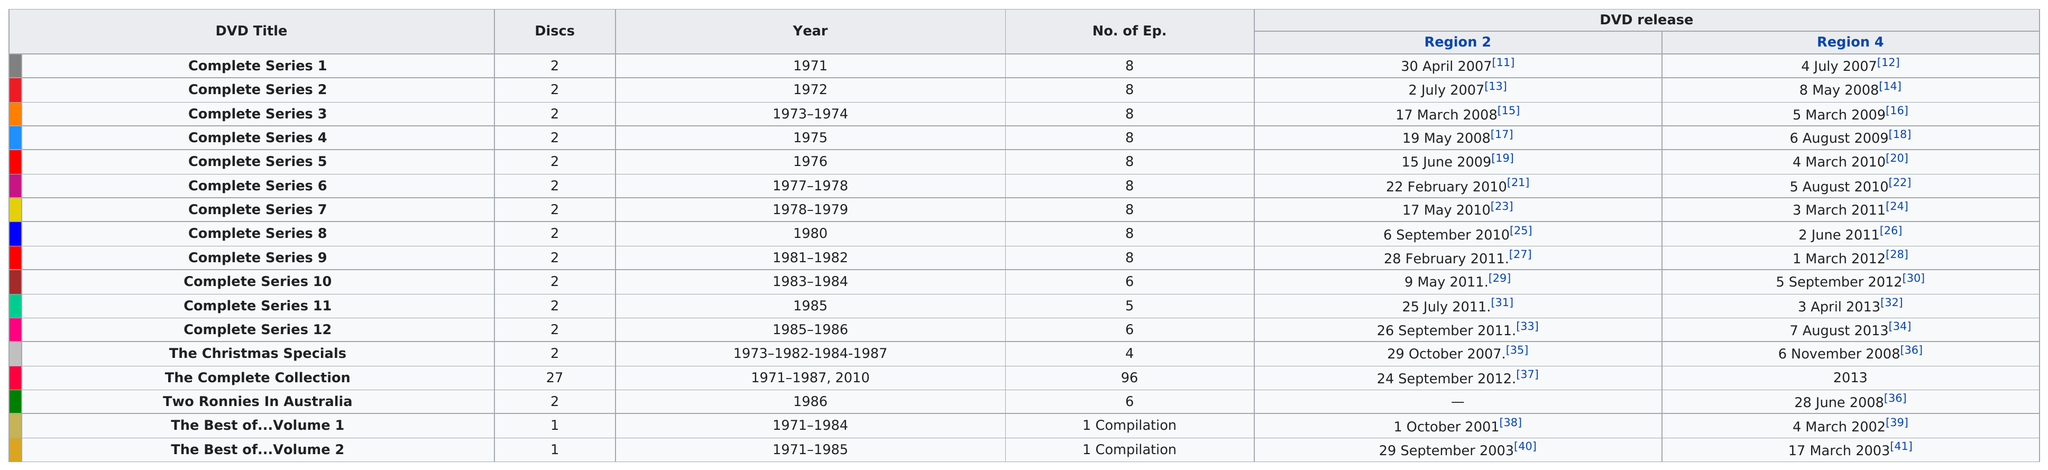Indicate a few pertinent items in this graphic. The phrase "what is previous to complete series 10? Complete Series 9.." is asking for information about the previous series to the currently available series, which is series 10, and also asking for information about the complete series of series 9. The DVD contains episodes that are shorter than five episodes, including the Christmas specials. I'm sorry, but I'm not sure what you mean by "how many series had 8 episodes? 9..". Could you please provide more context or clarify your question? The compilation of the top episodes of the television show "The Two Ronnies" is included in two "best of" volumes. The total number of episodes released in Region 2 in 2007 was 200. 